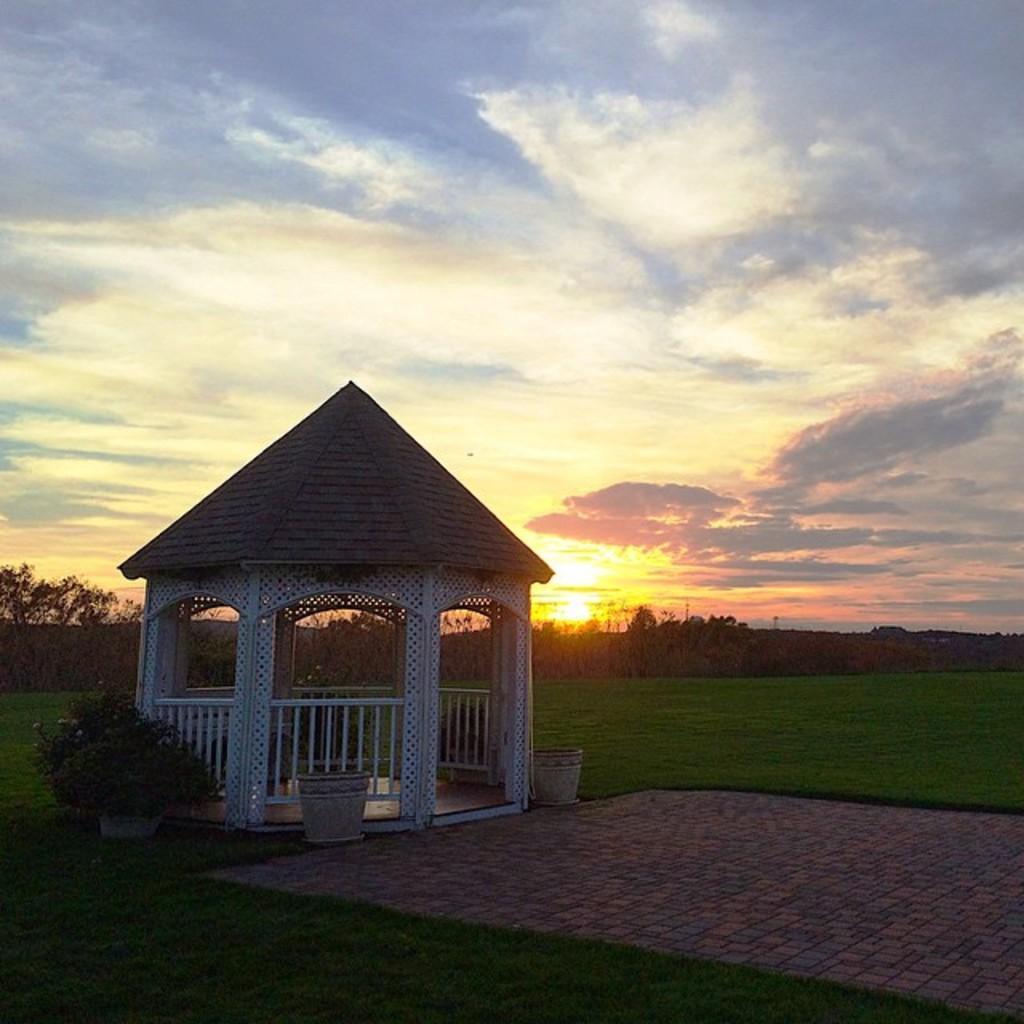Can you describe this image briefly? In this image we can see a gazebo with pillars and railings. On the ground there is grass. Near to that there are pots and plants. In the back there are trees. Also there is sky with clouds. 